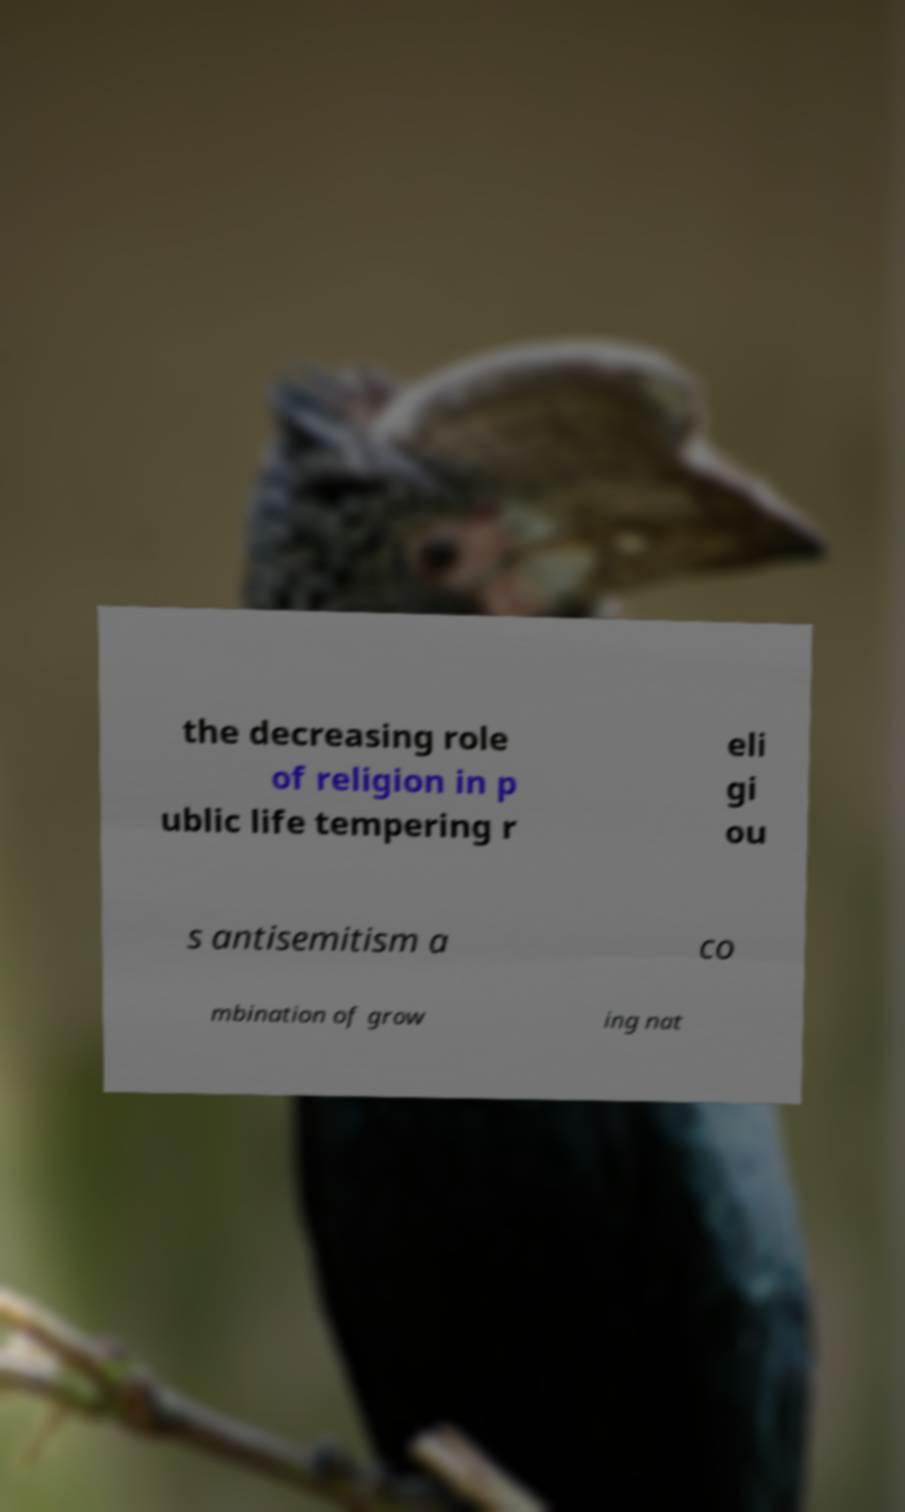Could you extract and type out the text from this image? the decreasing role of religion in p ublic life tempering r eli gi ou s antisemitism a co mbination of grow ing nat 